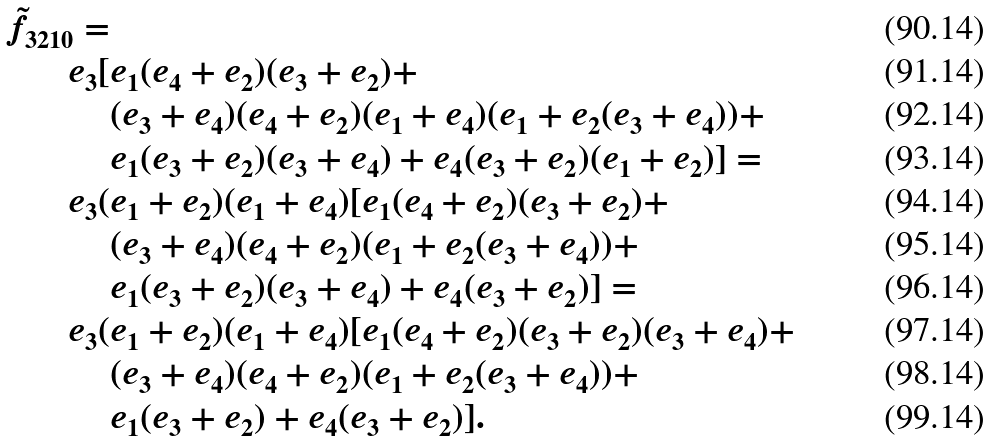Convert formula to latex. <formula><loc_0><loc_0><loc_500><loc_500>\tilde { f } _ { 3 2 1 0 } = & \\ e _ { 3 } [ & e _ { 1 } ( e _ { 4 } + e _ { 2 } ) ( e _ { 3 } + e _ { 2 } ) + \\ & ( e _ { 3 } + e _ { 4 } ) ( e _ { 4 } + e _ { 2 } ) ( e _ { 1 } + e _ { 4 } ) ( e _ { 1 } + e _ { 2 } ( e _ { 3 } + e _ { 4 } ) ) + \\ & e _ { 1 } ( e _ { 3 } + e _ { 2 } ) ( e _ { 3 } + e _ { 4 } ) + e _ { 4 } ( e _ { 3 } + e _ { 2 } ) ( e _ { 1 } + e _ { 2 } ) ] = \\ e _ { 3 } ( & e _ { 1 } + e _ { 2 } ) ( e _ { 1 } + e _ { 4 } ) [ e _ { 1 } ( e _ { 4 } + e _ { 2 } ) ( e _ { 3 } + e _ { 2 } ) + \\ & ( e _ { 3 } + e _ { 4 } ) ( e _ { 4 } + e _ { 2 } ) ( e _ { 1 } + e _ { 2 } ( e _ { 3 } + e _ { 4 } ) ) + \\ & e _ { 1 } ( e _ { 3 } + e _ { 2 } ) ( e _ { 3 } + e _ { 4 } ) + e _ { 4 } ( e _ { 3 } + e _ { 2 } ) ] = \\ e _ { 3 } ( & e _ { 1 } + e _ { 2 } ) ( e _ { 1 } + e _ { 4 } ) [ e _ { 1 } ( e _ { 4 } + e _ { 2 } ) ( e _ { 3 } + e _ { 2 } ) ( e _ { 3 } + e _ { 4 } ) + \\ & ( e _ { 3 } + e _ { 4 } ) ( e _ { 4 } + e _ { 2 } ) ( e _ { 1 } + e _ { 2 } ( e _ { 3 } + e _ { 4 } ) ) + \\ & e _ { 1 } ( e _ { 3 } + e _ { 2 } ) + e _ { 4 } ( e _ { 3 } + e _ { 2 } ) ] .</formula> 